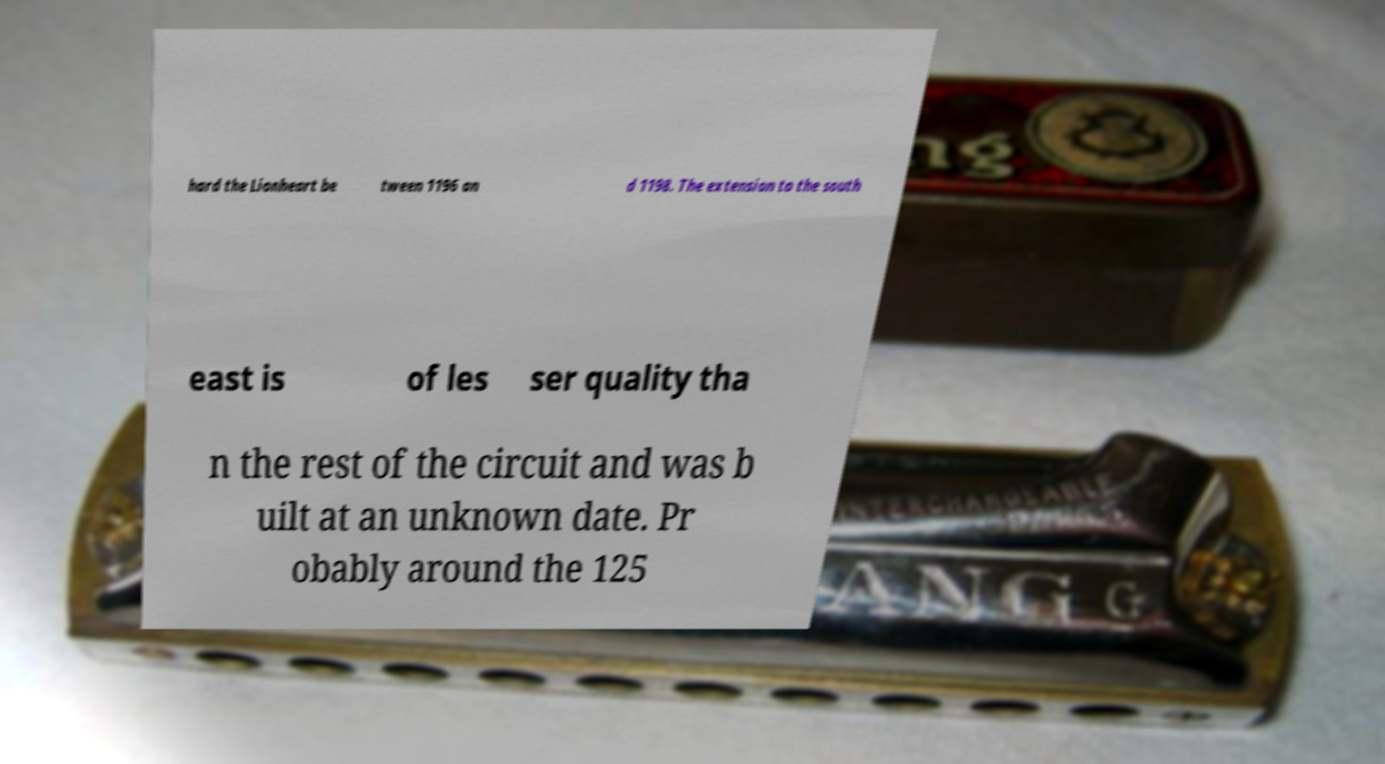Could you extract and type out the text from this image? hard the Lionheart be tween 1196 an d 1198. The extension to the south east is of les ser quality tha n the rest of the circuit and was b uilt at an unknown date. Pr obably around the 125 